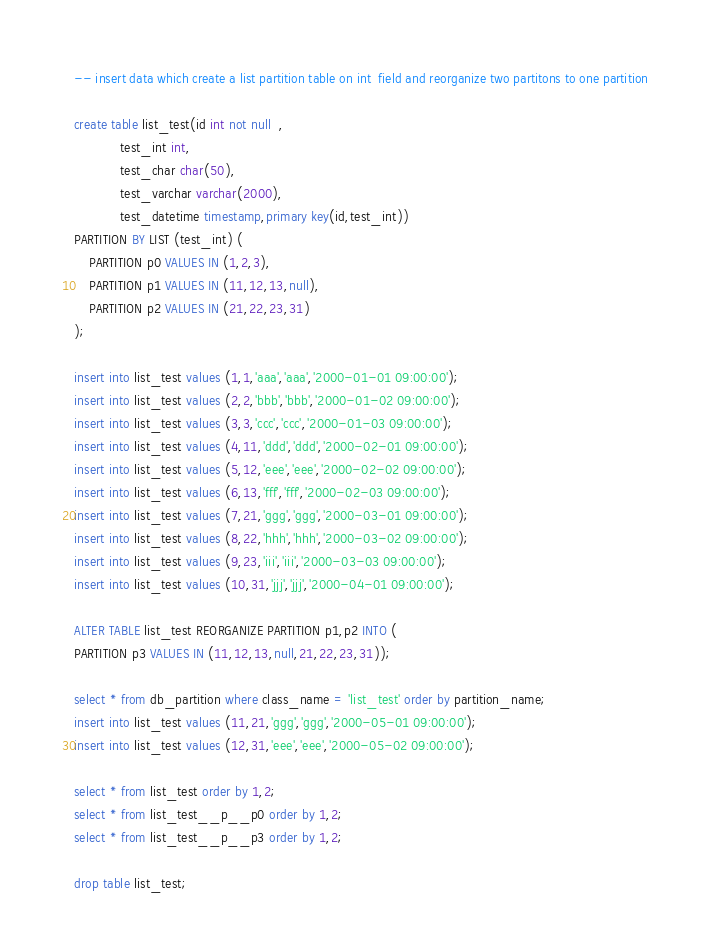<code> <loc_0><loc_0><loc_500><loc_500><_SQL_>-- insert data which create a list partition table on int  field and reorganize two partitons to one partition

create table list_test(id int not null  ,
			test_int int,
			test_char char(50),
			test_varchar varchar(2000),
			test_datetime timestamp,primary key(id,test_int))
PARTITION BY LIST (test_int) (
    PARTITION p0 VALUES IN (1,2,3),
    PARTITION p1 VALUES IN (11,12,13,null),
    PARTITION p2 VALUES IN (21,22,23,31)
);

insert into list_test values (1,1,'aaa','aaa','2000-01-01 09:00:00');
insert into list_test values (2,2,'bbb','bbb','2000-01-02 09:00:00');
insert into list_test values (3,3,'ccc','ccc','2000-01-03 09:00:00');
insert into list_test values (4,11,'ddd','ddd','2000-02-01 09:00:00');
insert into list_test values (5,12,'eee','eee','2000-02-02 09:00:00');
insert into list_test values (6,13,'fff','fff','2000-02-03 09:00:00');
insert into list_test values (7,21,'ggg','ggg','2000-03-01 09:00:00');
insert into list_test values (8,22,'hhh','hhh','2000-03-02 09:00:00');
insert into list_test values (9,23,'iii','iii','2000-03-03 09:00:00');
insert into list_test values (10,31,'jjj','jjj','2000-04-01 09:00:00');

ALTER TABLE list_test REORGANIZE PARTITION p1,p2 INTO ( 
PARTITION p3 VALUES IN (11,12,13,null,21,22,23,31));

select * from db_partition where class_name = 'list_test' order by partition_name;
insert into list_test values (11,21,'ggg','ggg','2000-05-01 09:00:00');
insert into list_test values (12,31,'eee','eee','2000-05-02 09:00:00');

select * from list_test order by 1,2;
select * from list_test__p__p0 order by 1,2;
select * from list_test__p__p3 order by 1,2;

drop table list_test;
</code> 